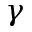<formula> <loc_0><loc_0><loc_500><loc_500>\gamma</formula> 